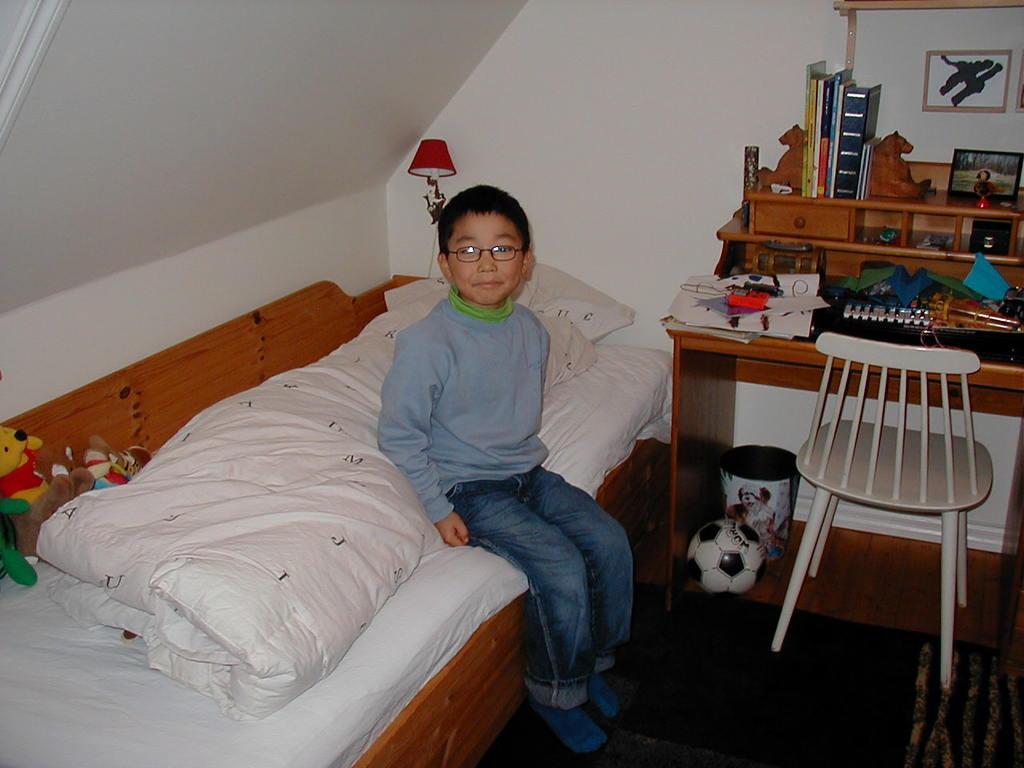In one or two sentences, can you explain what this image depicts? This picture is clicked in a room. The boy in blue t-shirt and blue pant is sitting on bed. Beside him, we see a table on which keyboard, papers, books and photo frame are placed. Under the table, we see dustbin and ball. Behind him, we see a red lamp and a white wall. 